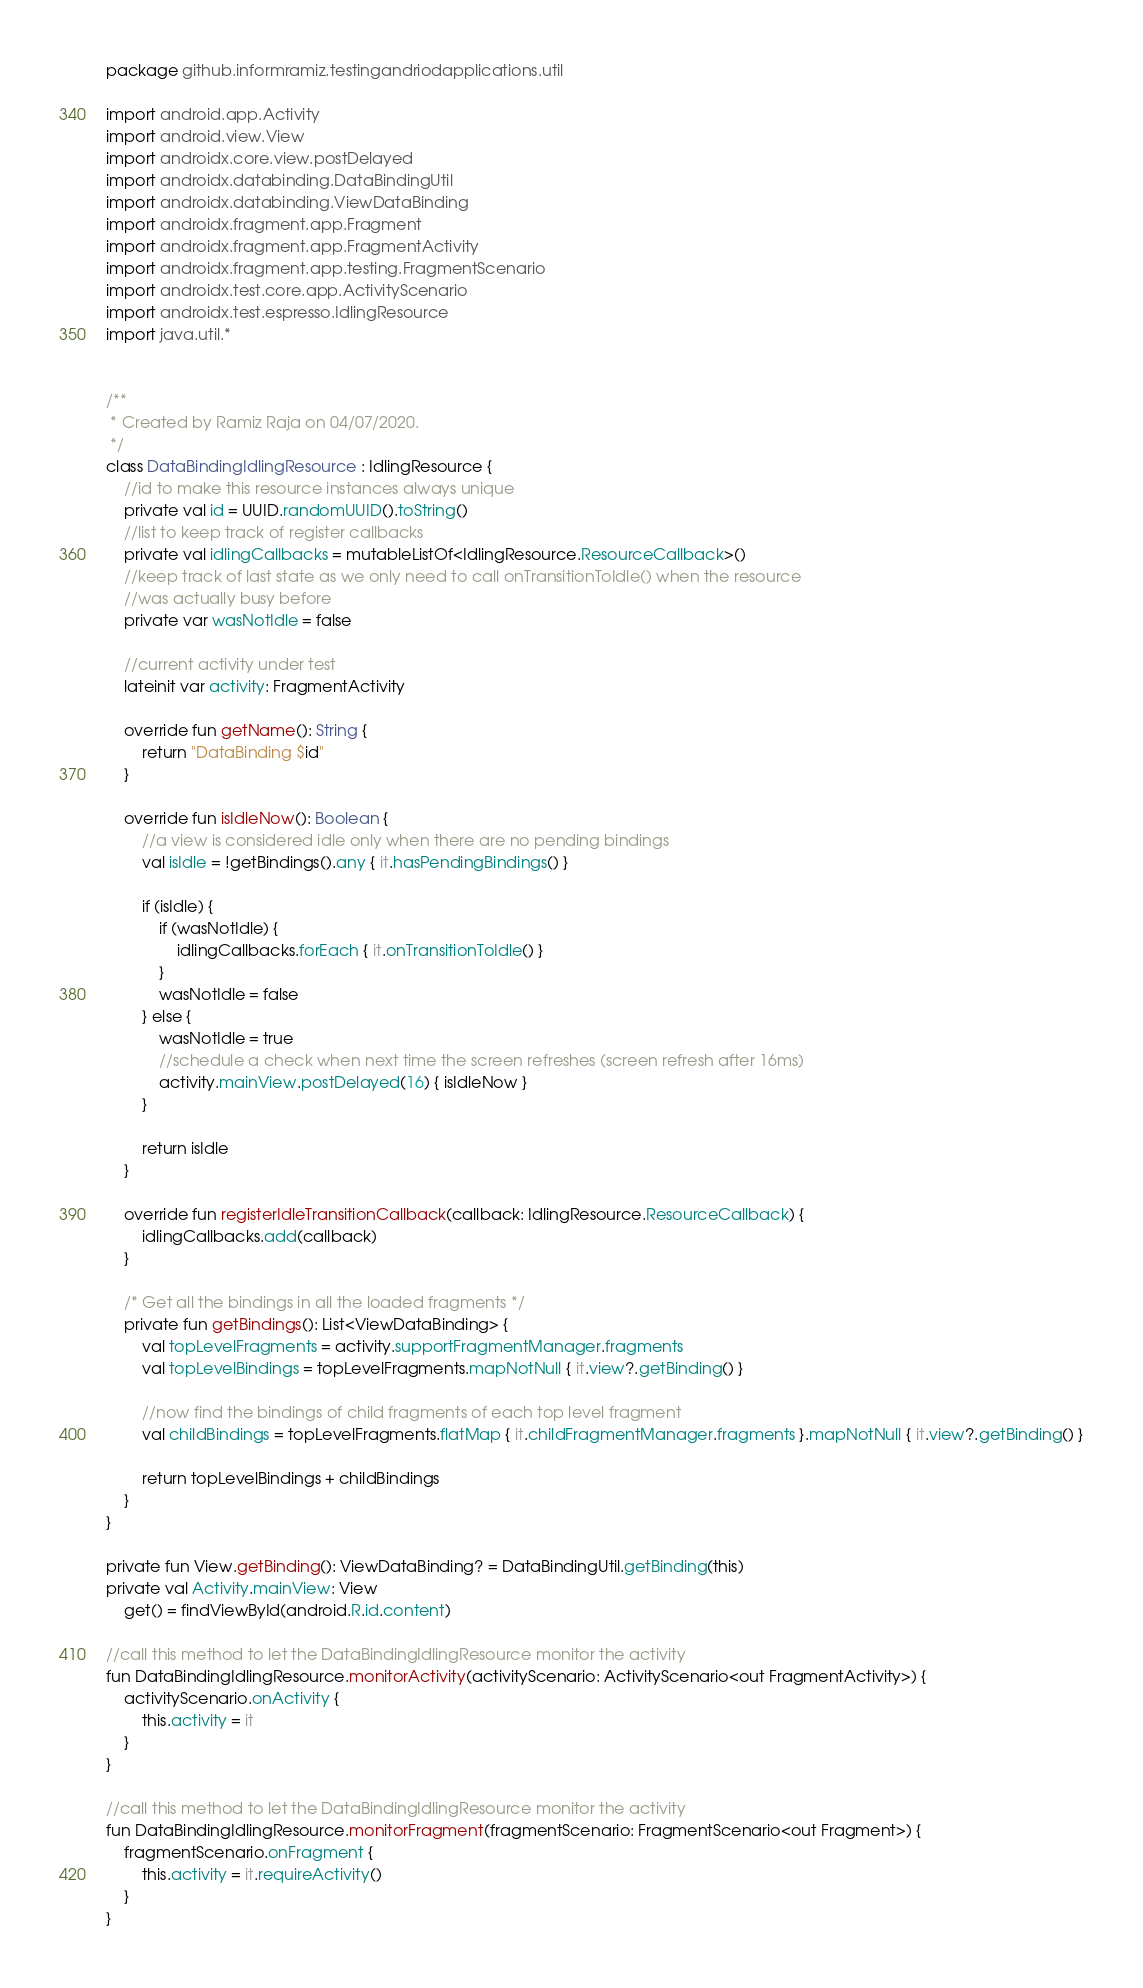<code> <loc_0><loc_0><loc_500><loc_500><_Kotlin_>package github.informramiz.testingandriodapplications.util

import android.app.Activity
import android.view.View
import androidx.core.view.postDelayed
import androidx.databinding.DataBindingUtil
import androidx.databinding.ViewDataBinding
import androidx.fragment.app.Fragment
import androidx.fragment.app.FragmentActivity
import androidx.fragment.app.testing.FragmentScenario
import androidx.test.core.app.ActivityScenario
import androidx.test.espresso.IdlingResource
import java.util.*


/**
 * Created by Ramiz Raja on 04/07/2020.
 */
class DataBindingIdlingResource : IdlingResource {
    //id to make this resource instances always unique
    private val id = UUID.randomUUID().toString()
    //list to keep track of register callbacks
    private val idlingCallbacks = mutableListOf<IdlingResource.ResourceCallback>()
    //keep track of last state as we only need to call onTransitionToIdle() when the resource
    //was actually busy before
    private var wasNotIdle = false

    //current activity under test
    lateinit var activity: FragmentActivity

    override fun getName(): String {
        return "DataBinding $id"
    }

    override fun isIdleNow(): Boolean {
        //a view is considered idle only when there are no pending bindings
        val isIdle = !getBindings().any { it.hasPendingBindings() }

        if (isIdle) {
            if (wasNotIdle) {
                idlingCallbacks.forEach { it.onTransitionToIdle() }
            }
            wasNotIdle = false
        } else {
            wasNotIdle = true
            //schedule a check when next time the screen refreshes (screen refresh after 16ms)
            activity.mainView.postDelayed(16) { isIdleNow }
        }

        return isIdle
    }

    override fun registerIdleTransitionCallback(callback: IdlingResource.ResourceCallback) {
        idlingCallbacks.add(callback)
    }

    /* Get all the bindings in all the loaded fragments */
    private fun getBindings(): List<ViewDataBinding> {
        val topLevelFragments = activity.supportFragmentManager.fragments
        val topLevelBindings = topLevelFragments.mapNotNull { it.view?.getBinding() }

        //now find the bindings of child fragments of each top level fragment
        val childBindings = topLevelFragments.flatMap { it.childFragmentManager.fragments }.mapNotNull { it.view?.getBinding() }

        return topLevelBindings + childBindings
    }
}

private fun View.getBinding(): ViewDataBinding? = DataBindingUtil.getBinding(this)
private val Activity.mainView: View
    get() = findViewById(android.R.id.content)

//call this method to let the DataBindingIdlingResource monitor the activity
fun DataBindingIdlingResource.monitorActivity(activityScenario: ActivityScenario<out FragmentActivity>) {
    activityScenario.onActivity {
        this.activity = it
    }
}

//call this method to let the DataBindingIdlingResource monitor the activity
fun DataBindingIdlingResource.monitorFragment(fragmentScenario: FragmentScenario<out Fragment>) {
    fragmentScenario.onFragment {
        this.activity = it.requireActivity()
    }
}</code> 